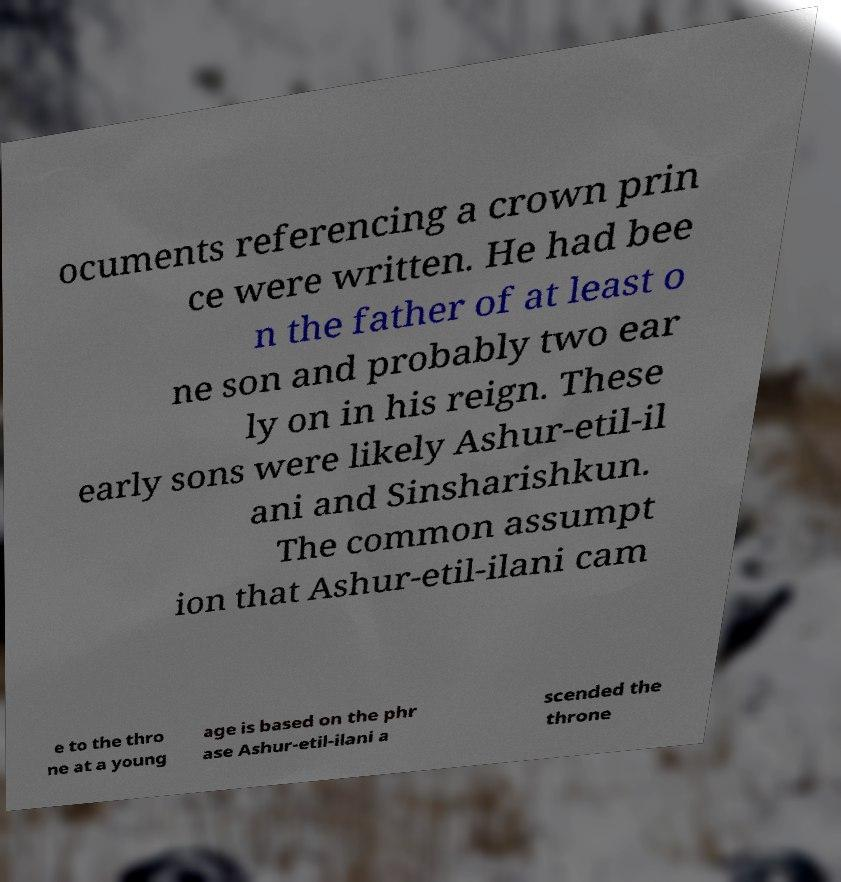For documentation purposes, I need the text within this image transcribed. Could you provide that? ocuments referencing a crown prin ce were written. He had bee n the father of at least o ne son and probably two ear ly on in his reign. These early sons were likely Ashur-etil-il ani and Sinsharishkun. The common assumpt ion that Ashur-etil-ilani cam e to the thro ne at a young age is based on the phr ase Ashur-etil-ilani a scended the throne 